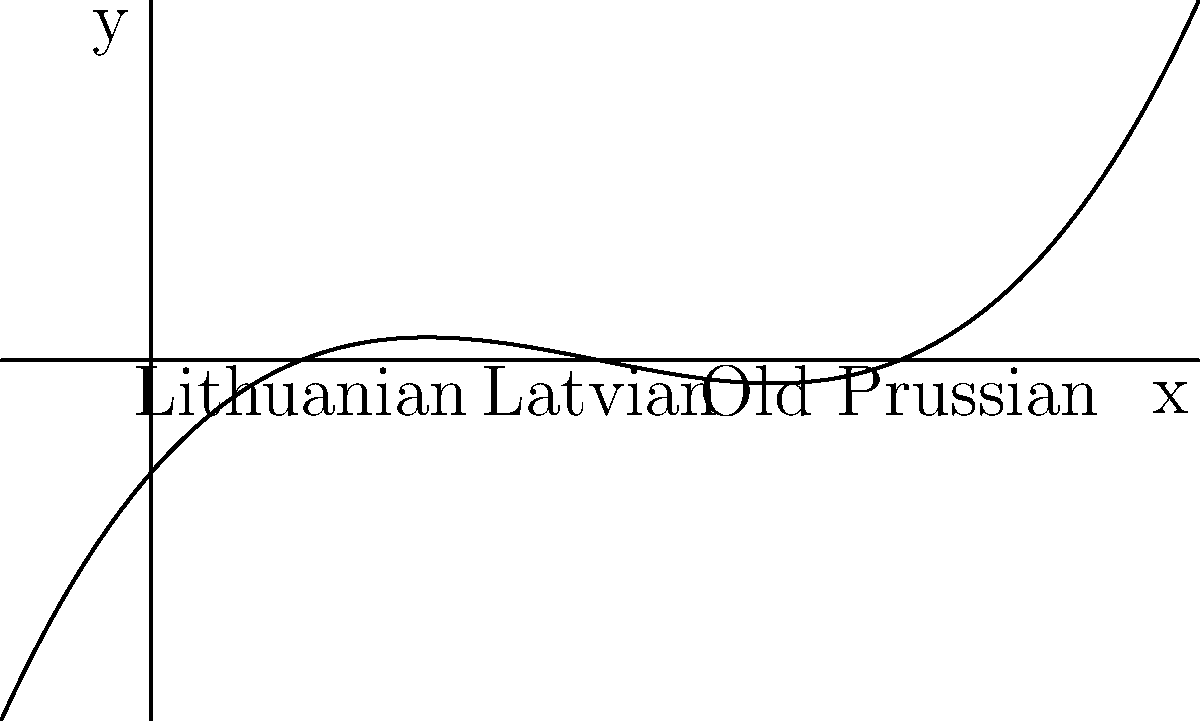The polynomial $f(x) = 0.05(x-1)(x-3)(x-5)$ represents the distribution of Baltic language speakers across different regions. The roots of this polynomial correspond to the locations of peak speaker concentrations for Lithuanian, Latvian, and Old Prussian. If you were to travel from west to east, in what order would you encounter these language concentrations? To determine the order of language concentrations from west to east, we need to analyze the roots of the polynomial:

1. The roots of the polynomial are the x-intercepts of the graph, which occur at $x = 1$, $x = 3$, and $x = 5$.

2. These roots correspond to the peak concentrations of the three Baltic languages:
   - $x = 1$ represents Lithuanian
   - $x = 3$ represents Latvian
   - $x = 5$ represents Old Prussian

3. On a west-east axis, smaller x-values are more westward, while larger x-values are more eastward.

4. Ordering the x-values from smallest to largest gives us:
   1 < 3 < 5

5. Therefore, the order of language concentrations from west to east is:
   Lithuanian (x = 1) → Latvian (x = 3) → Old Prussian (x = 5)
Answer: Lithuanian, Latvian, Old Prussian 